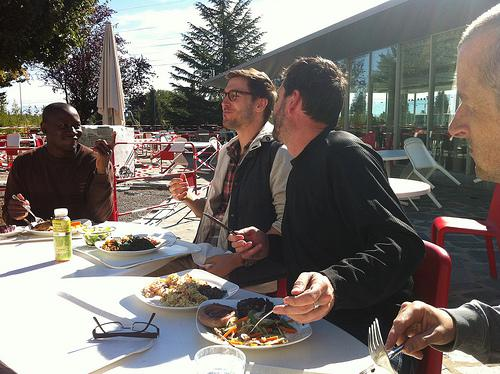Question: why are people sitting at the table?
Choices:
A. To eat.
B. To play poker.
C. To do business.
D. To talk.
Answer with the letter. Answer: A Question: who is in the photo?
Choices:
A. Four men.
B. A group of children.
C. A politician.
D. A celebrity.
Answer with the letter. Answer: A Question: how many men are in the photo?
Choices:
A. Two.
B. Four.
C. One.
D. Three.
Answer with the letter. Answer: B Question: what are the men doing?
Choices:
A. Eating and talking.
B. Running.
C. Swimming.
D. Fighting.
Answer with the letter. Answer: A Question: where was the photo taken?
Choices:
A. In a theatre.
B. In a supermarket.
C. In a bar.
D. In a restaurant.
Answer with the letter. Answer: D 